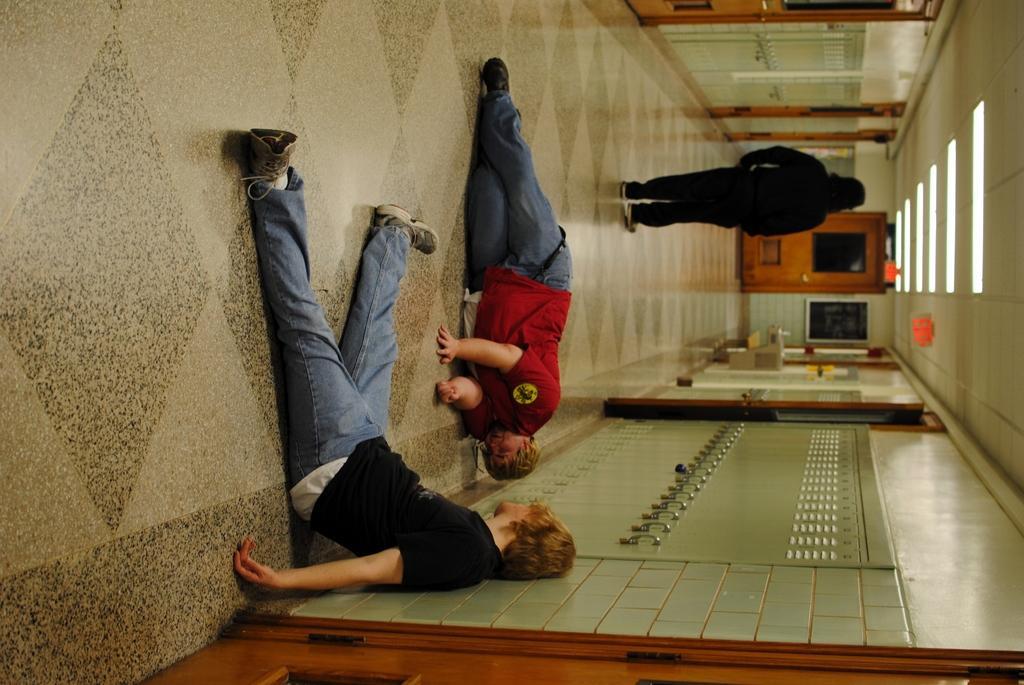Can you describe this image briefly? In this image there is a person sitting on the floor, a person laying on the floor, another person standing, and there are lockers, lights, frame attached to the wall, doors. 